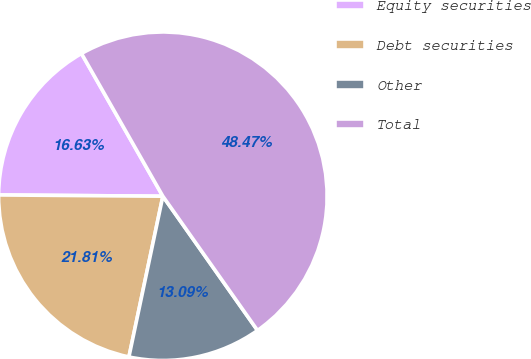Convert chart to OTSL. <chart><loc_0><loc_0><loc_500><loc_500><pie_chart><fcel>Equity securities<fcel>Debt securities<fcel>Other<fcel>Total<nl><fcel>16.63%<fcel>21.81%<fcel>13.09%<fcel>48.47%<nl></chart> 